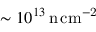Convert formula to latex. <formula><loc_0><loc_0><loc_500><loc_500>\sim 1 0 ^ { 1 3 } \, n \, c m ^ { - 2 }</formula> 